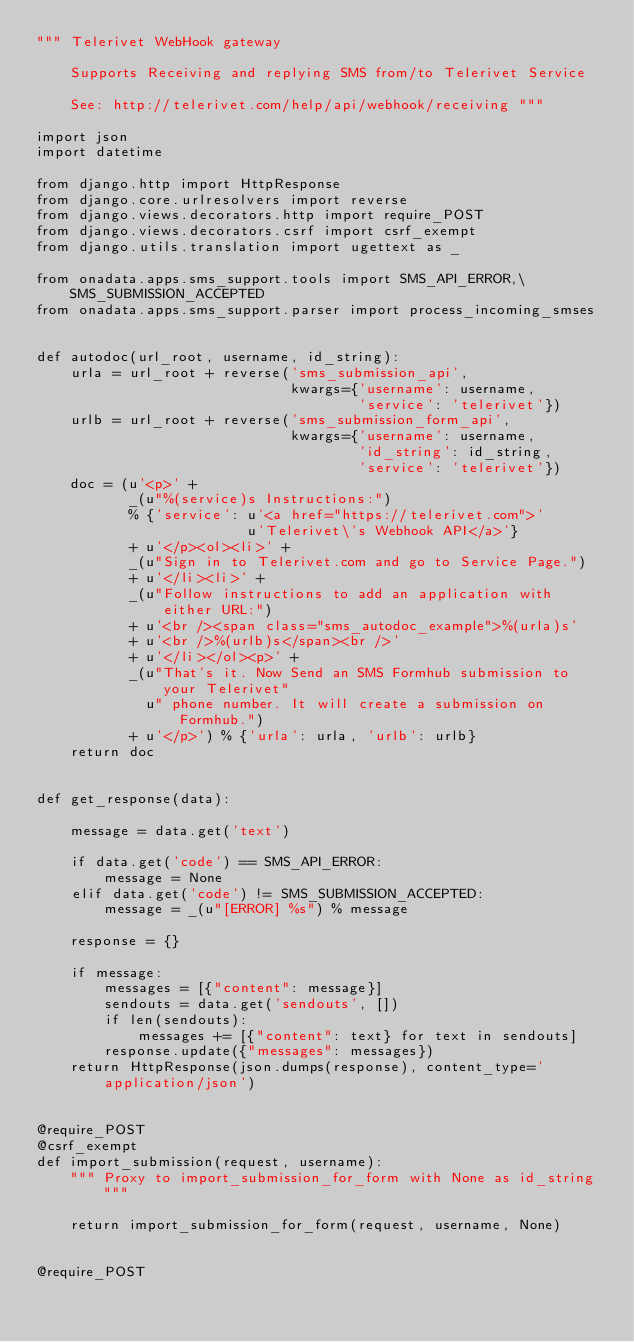<code> <loc_0><loc_0><loc_500><loc_500><_Python_>""" Telerivet WebHook gateway

    Supports Receiving and replying SMS from/to Telerivet Service

    See: http://telerivet.com/help/api/webhook/receiving """

import json
import datetime

from django.http import HttpResponse
from django.core.urlresolvers import reverse
from django.views.decorators.http import require_POST
from django.views.decorators.csrf import csrf_exempt
from django.utils.translation import ugettext as _

from onadata.apps.sms_support.tools import SMS_API_ERROR,\
    SMS_SUBMISSION_ACCEPTED
from onadata.apps.sms_support.parser import process_incoming_smses


def autodoc(url_root, username, id_string):
    urla = url_root + reverse('sms_submission_api',
                              kwargs={'username': username,
                                      'service': 'telerivet'})
    urlb = url_root + reverse('sms_submission_form_api',
                              kwargs={'username': username,
                                      'id_string': id_string,
                                      'service': 'telerivet'})
    doc = (u'<p>' +
           _(u"%(service)s Instructions:")
           % {'service': u'<a href="https://telerivet.com">'
                         u'Telerivet\'s Webhook API</a>'}
           + u'</p><ol><li>' +
           _(u"Sign in to Telerivet.com and go to Service Page.")
           + u'</li><li>' +
           _(u"Follow instructions to add an application with either URL:")
           + u'<br /><span class="sms_autodoc_example">%(urla)s'
           + u'<br />%(urlb)s</span><br />'
           + u'</li></ol><p>' +
           _(u"That's it. Now Send an SMS Formhub submission to your Telerivet"
             u" phone number. It will create a submission on Formhub.")
           + u'</p>') % {'urla': urla, 'urlb': urlb}
    return doc


def get_response(data):

    message = data.get('text')

    if data.get('code') == SMS_API_ERROR:
        message = None
    elif data.get('code') != SMS_SUBMISSION_ACCEPTED:
        message = _(u"[ERROR] %s") % message

    response = {}

    if message:
        messages = [{"content": message}]
        sendouts = data.get('sendouts', [])
        if len(sendouts):
            messages += [{"content": text} for text in sendouts]
        response.update({"messages": messages})
    return HttpResponse(json.dumps(response), content_type='application/json')


@require_POST
@csrf_exempt
def import_submission(request, username):
    """ Proxy to import_submission_for_form with None as id_string """

    return import_submission_for_form(request, username, None)


@require_POST</code> 